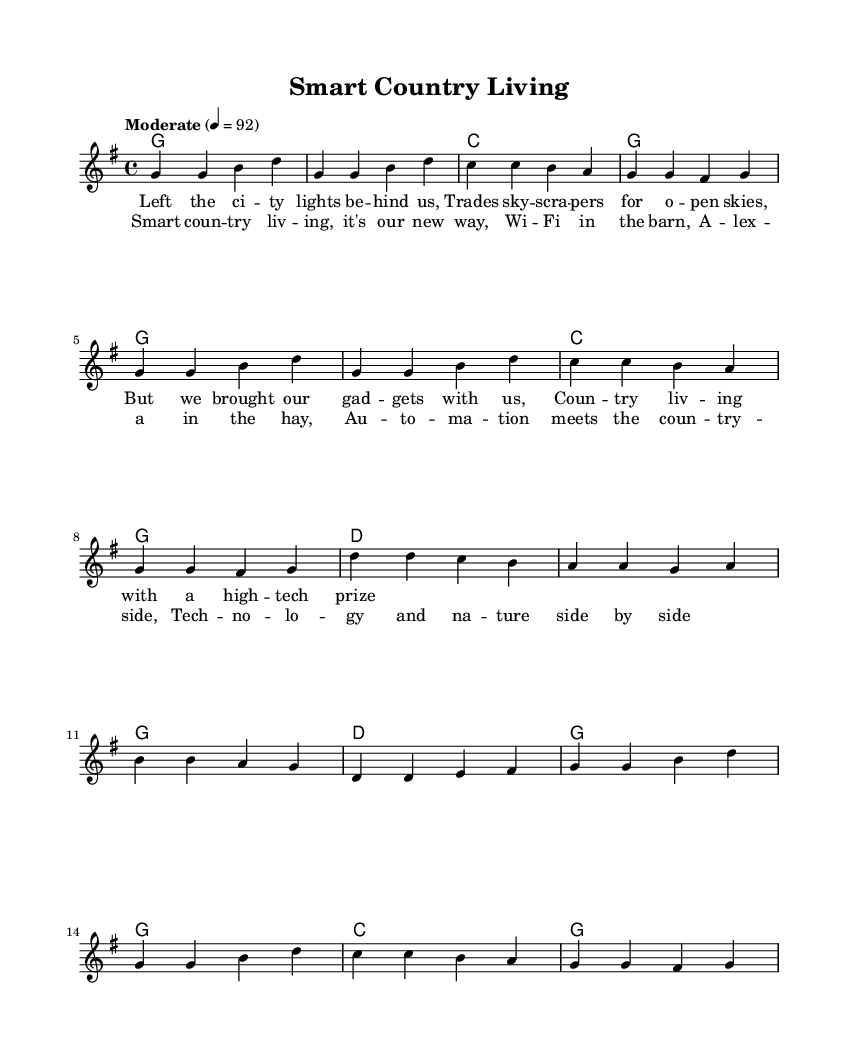What is the key signature of this music? The key signature indicates G major, which has one sharp (F#). The G major key signature can be identified by the note placement in the treble clef.
Answer: G major What is the time signature of this music? The time signature appears at the beginning, showing 4/4 time. In this case, there are four beats in each measure, which is typical for country music.
Answer: 4/4 What is the tempo marking for this piece? The tempo marking is "Moderate" with a metronomic tempo indication of 92 beats per minute. This can be found at the beginning of the score.
Answer: Moderate 92 How many measures are in the verse section? By counting the measures consisting of separate phrases, we see that there are eight measures in the verse. Specifically, we can group the measures containing lyrics to identify the sections.
Answer: Eight measures What are the first lyrics in the verse? The first lyrics of the verse are "Left the city lights behind us." This can be found in the lyric mode section below the melody.
Answer: Left the city lights behind us What harmonic progression is used in the chorus? The harmonic progression in the chorus begins with D major, followed by G major and then C major before returning to G major. This progression includes common movements in country music.
Answer: D, G, C, G What is the overall theme of this song? The overall theme of the song revolves around transitioning from city life to smart country living, incorporating technology into rural experiences. This is reflected in the lyrics describing the blend of tech and nature.
Answer: Transitioning from city to country 